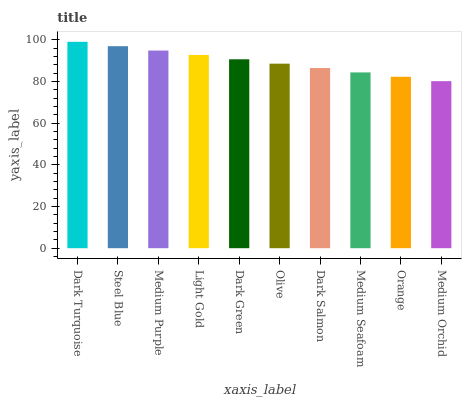Is Medium Orchid the minimum?
Answer yes or no. Yes. Is Dark Turquoise the maximum?
Answer yes or no. Yes. Is Steel Blue the minimum?
Answer yes or no. No. Is Steel Blue the maximum?
Answer yes or no. No. Is Dark Turquoise greater than Steel Blue?
Answer yes or no. Yes. Is Steel Blue less than Dark Turquoise?
Answer yes or no. Yes. Is Steel Blue greater than Dark Turquoise?
Answer yes or no. No. Is Dark Turquoise less than Steel Blue?
Answer yes or no. No. Is Dark Green the high median?
Answer yes or no. Yes. Is Olive the low median?
Answer yes or no. Yes. Is Medium Orchid the high median?
Answer yes or no. No. Is Medium Orchid the low median?
Answer yes or no. No. 